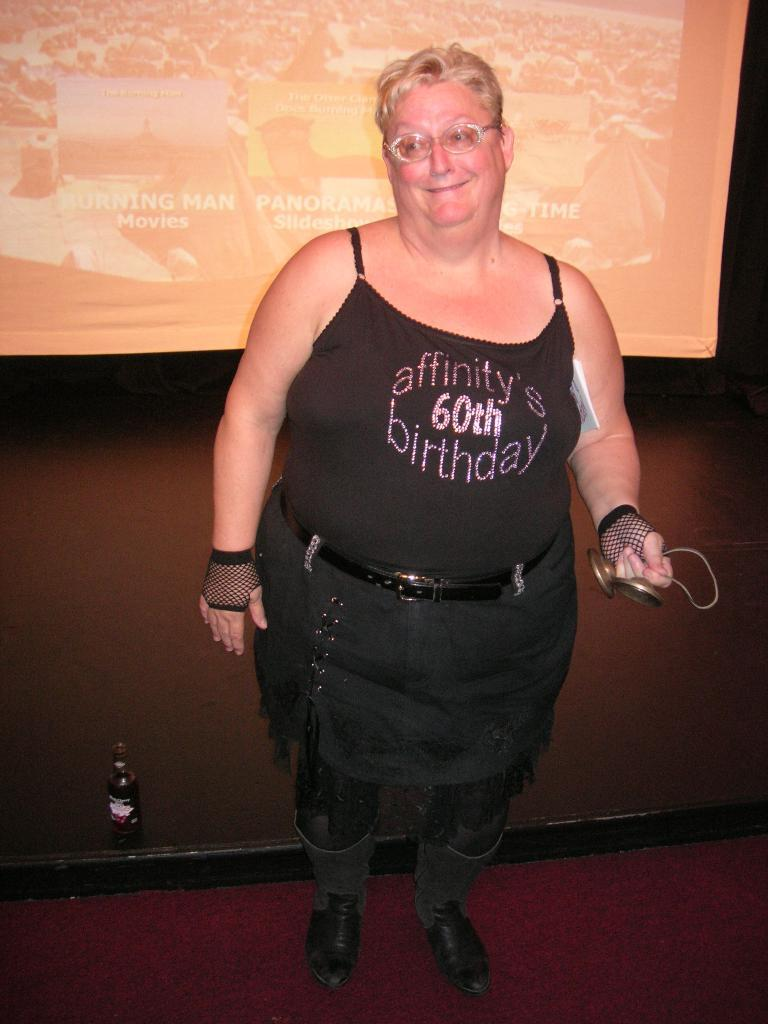What is the main subject of the image? There is a man standing in the image. Where is the man positioned in the image? The man is standing on the floor. What can be seen in the background of the image? There is a display screen and a beverage bottle in the background of the image. What song is the man singing in the image? There is no indication in the image that the man is singing, and therefore no song can be identified. 